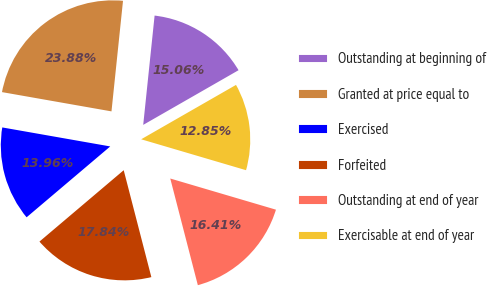Convert chart. <chart><loc_0><loc_0><loc_500><loc_500><pie_chart><fcel>Outstanding at beginning of<fcel>Granted at price equal to<fcel>Exercised<fcel>Forfeited<fcel>Outstanding at end of year<fcel>Exercisable at end of year<nl><fcel>15.06%<fcel>23.88%<fcel>13.96%<fcel>17.84%<fcel>16.41%<fcel>12.85%<nl></chart> 